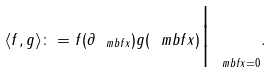<formula> <loc_0><loc_0><loc_500><loc_500>\langle f , g \rangle \colon = f ( \partial _ { \ m b f { x } } ) g ( \ m b f { x } ) \Big | _ { \ m b f { x } = 0 } .</formula> 